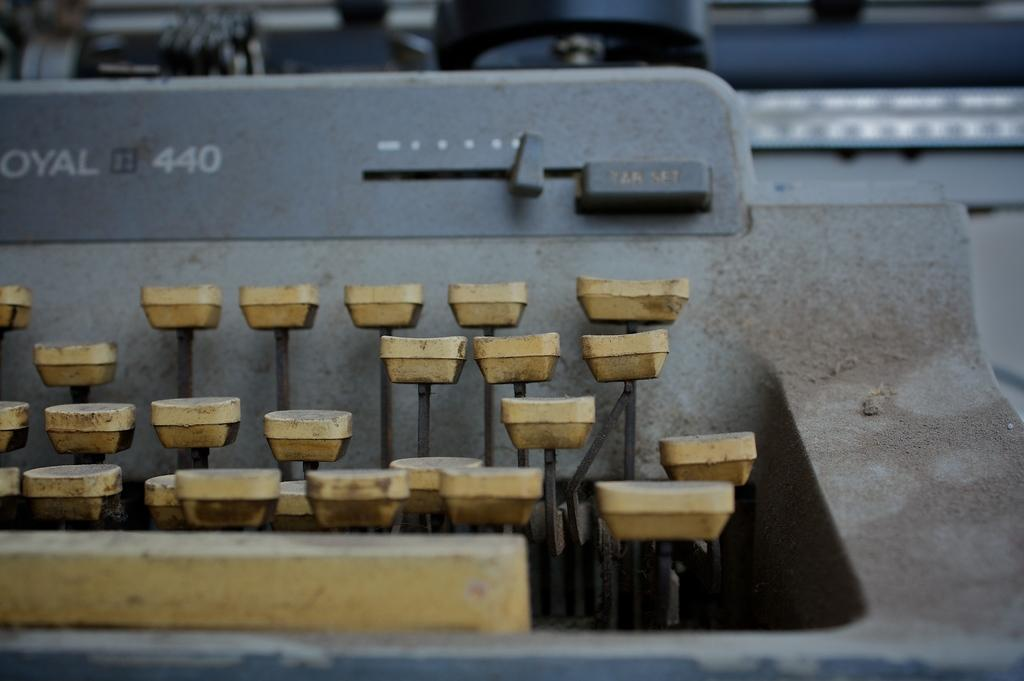<image>
Offer a succinct explanation of the picture presented. An old typewriter is a Royal 440 model and is quite dirty. 